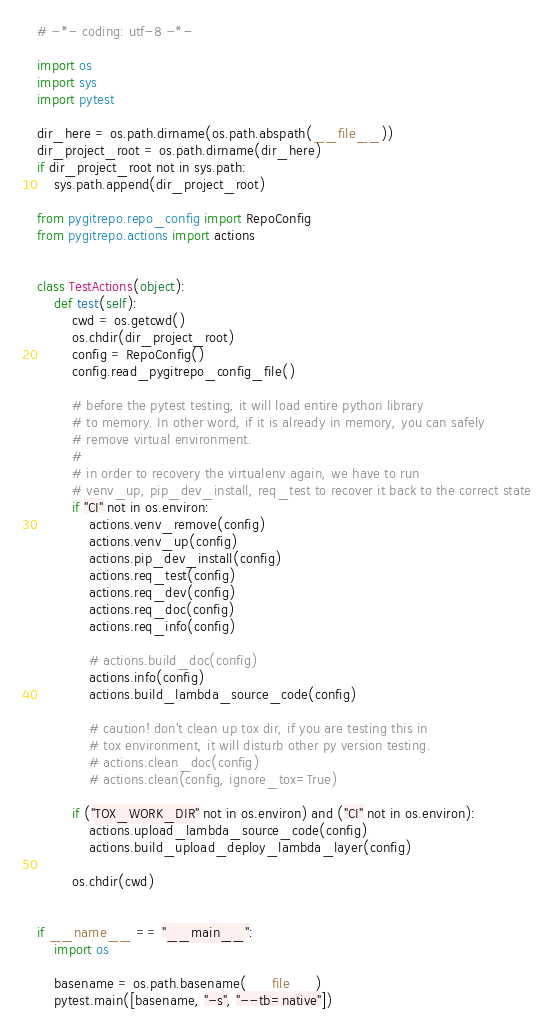<code> <loc_0><loc_0><loc_500><loc_500><_Python_># -*- coding: utf-8 -*-

import os
import sys
import pytest

dir_here = os.path.dirname(os.path.abspath(__file__))
dir_project_root = os.path.dirname(dir_here)
if dir_project_root not in sys.path:
    sys.path.append(dir_project_root)

from pygitrepo.repo_config import RepoConfig
from pygitrepo.actions import actions


class TestActions(object):
    def test(self):
        cwd = os.getcwd()
        os.chdir(dir_project_root)
        config = RepoConfig()
        config.read_pygitrepo_config_file()

        # before the pytest testing, it will load entire python library
        # to memory. In other word, if it is already in memory, you can safely
        # remove virtual environment.
        #
        # in order to recovery the virtualenv again, we have to run
        # venv_up, pip_dev_install, req_test to recover it back to the correct state
        if "CI" not in os.environ:
            actions.venv_remove(config)
            actions.venv_up(config)
            actions.pip_dev_install(config)
            actions.req_test(config)
            actions.req_dev(config)
            actions.req_doc(config)
            actions.req_info(config)

            # actions.build_doc(config)
            actions.info(config)
            actions.build_lambda_source_code(config)

            # caution! don't clean up tox dir, if you are testing this in
            # tox environment, it will disturb other py version testing.
            # actions.clean_doc(config)
            # actions.clean(config, ignore_tox=True)

        if ("TOX_WORK_DIR" not in os.environ) and ("CI" not in os.environ):
            actions.upload_lambda_source_code(config)
            actions.build_upload_deploy_lambda_layer(config)

        os.chdir(cwd)


if __name__ == "__main__":
    import os

    basename = os.path.basename(__file__)
    pytest.main([basename, "-s", "--tb=native"])
</code> 